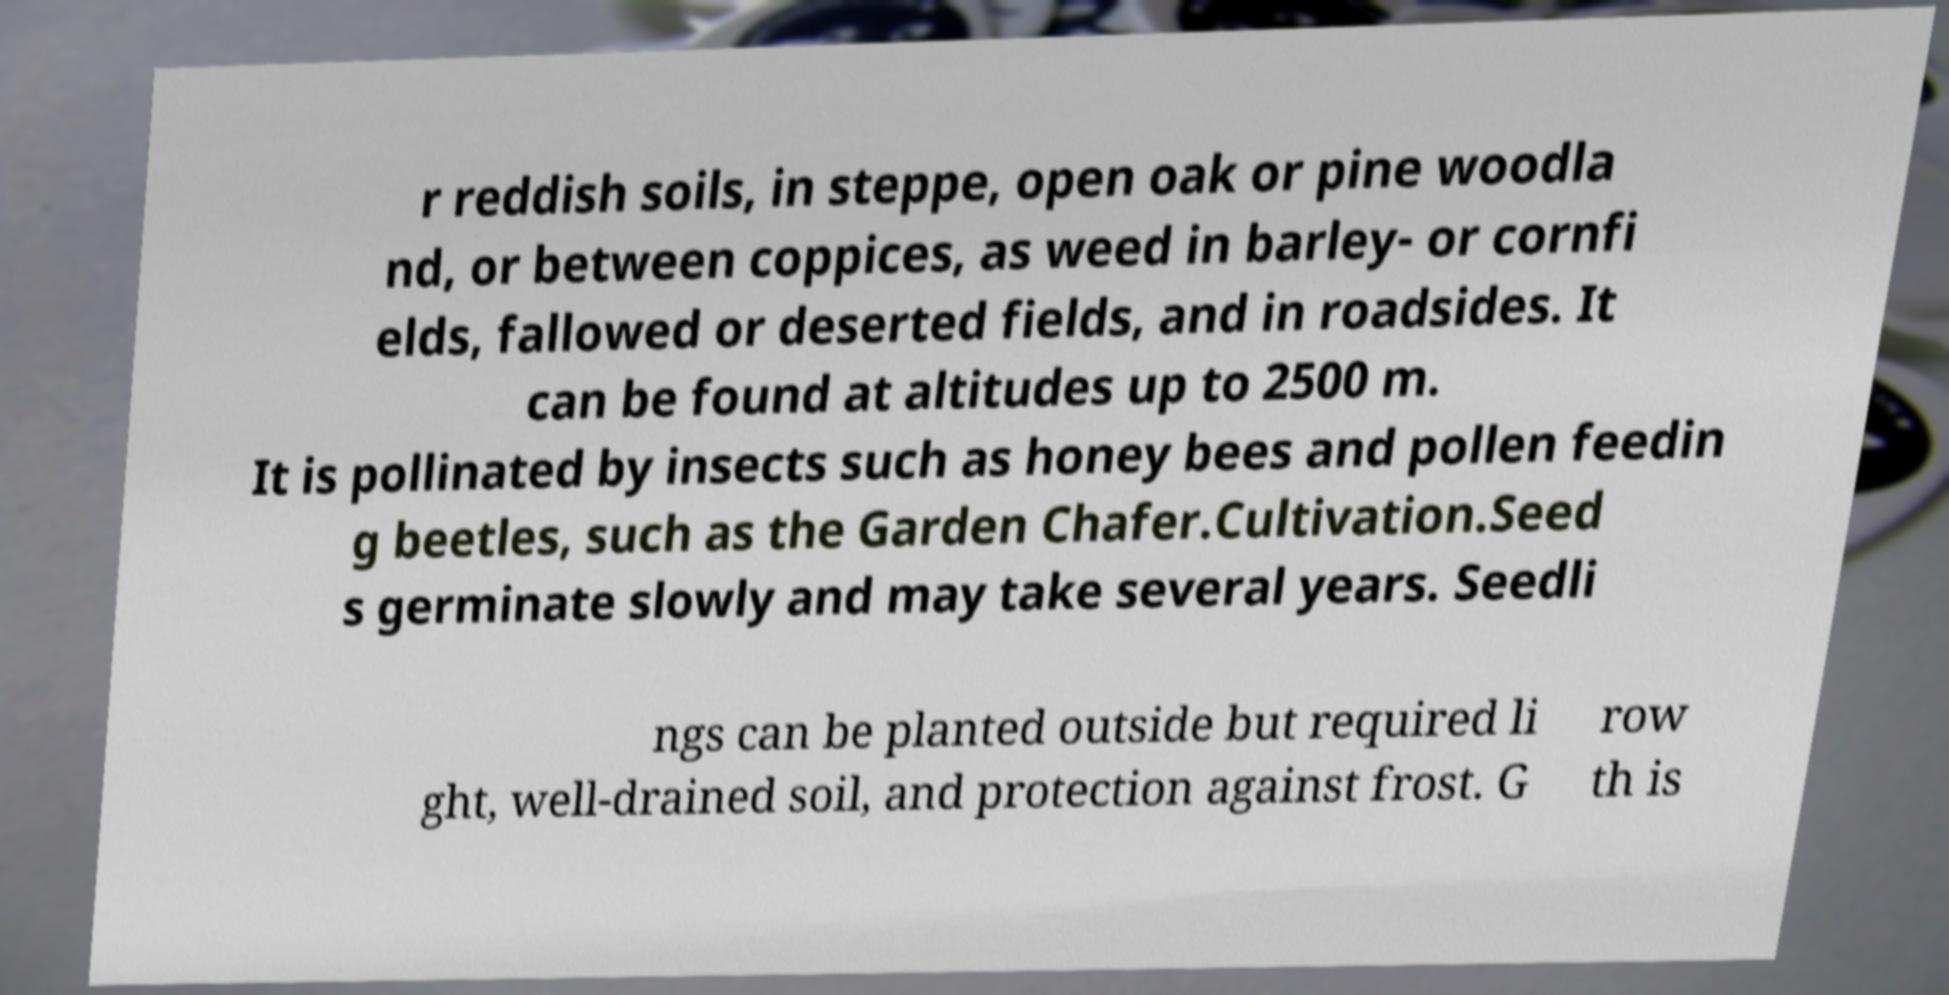I need the written content from this picture converted into text. Can you do that? r reddish soils, in steppe, open oak or pine woodla nd, or between coppices, as weed in barley- or cornfi elds, fallowed or deserted fields, and in roadsides. It can be found at altitudes up to 2500 m. It is pollinated by insects such as honey bees and pollen feedin g beetles, such as the Garden Chafer.Cultivation.Seed s germinate slowly and may take several years. Seedli ngs can be planted outside but required li ght, well-drained soil, and protection against frost. G row th is 